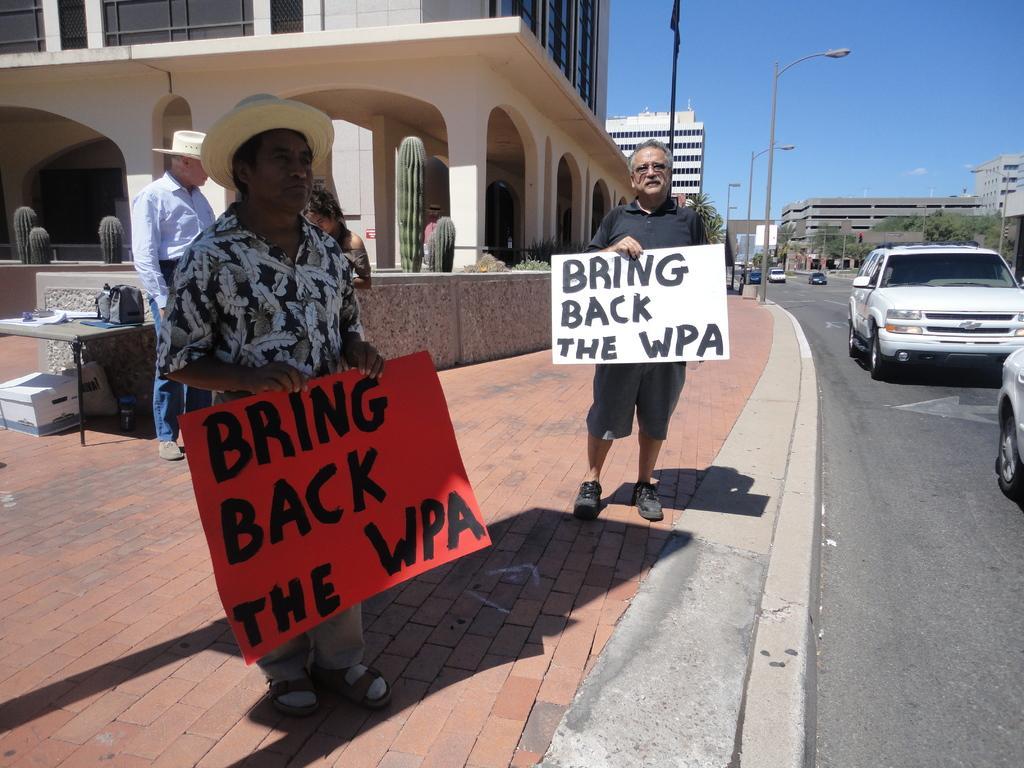Please provide a concise description of this image. In this image i can see there is a man who is holding a board in his hands. And there are couple of vehicles on the road and few buildings. 